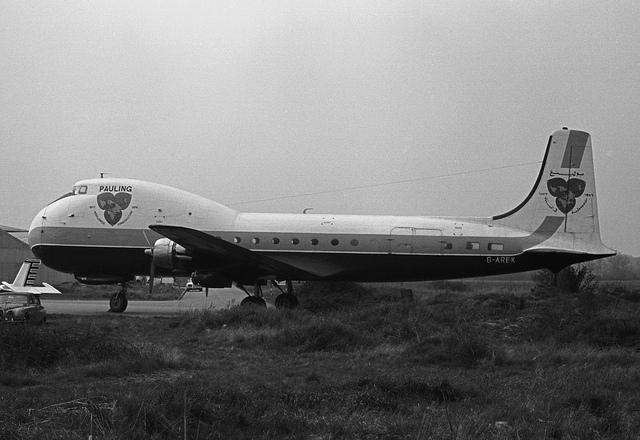How many engines on the plane?
Keep it brief. 2. Is the photo colored?
Answer briefly. No. Is this an old airplane?
Keep it brief. Yes. 